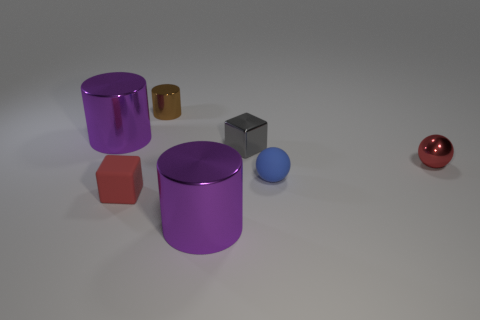What could be the purpose or theme of arranging these objects in such a manner? The arrangement might be purely aesthetic, designed to create an appealing visual composition through contrasting colors and shapes. It could also be practical, perhaps in a retail display to attract attention or highlight the variety of items. Alternatively, this could be an educational setup, used to teach about geometry, color theory, or material properties. The intent behind the arrangement is open to interpretation and could pivot on the context in which it's viewed. 